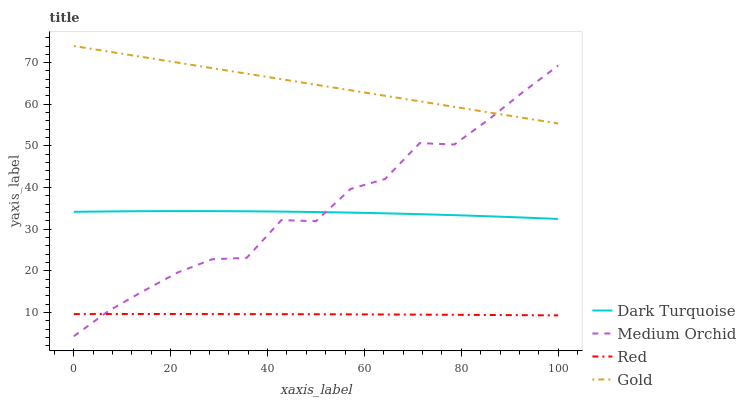Does Red have the minimum area under the curve?
Answer yes or no. Yes. Does Gold have the maximum area under the curve?
Answer yes or no. Yes. Does Medium Orchid have the minimum area under the curve?
Answer yes or no. No. Does Medium Orchid have the maximum area under the curve?
Answer yes or no. No. Is Gold the smoothest?
Answer yes or no. Yes. Is Medium Orchid the roughest?
Answer yes or no. Yes. Is Medium Orchid the smoothest?
Answer yes or no. No. Is Gold the roughest?
Answer yes or no. No. Does Medium Orchid have the lowest value?
Answer yes or no. Yes. Does Gold have the lowest value?
Answer yes or no. No. Does Gold have the highest value?
Answer yes or no. Yes. Does Medium Orchid have the highest value?
Answer yes or no. No. Is Red less than Gold?
Answer yes or no. Yes. Is Gold greater than Red?
Answer yes or no. Yes. Does Medium Orchid intersect Gold?
Answer yes or no. Yes. Is Medium Orchid less than Gold?
Answer yes or no. No. Is Medium Orchid greater than Gold?
Answer yes or no. No. Does Red intersect Gold?
Answer yes or no. No. 